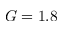Convert formula to latex. <formula><loc_0><loc_0><loc_500><loc_500>G = 1 . 8</formula> 